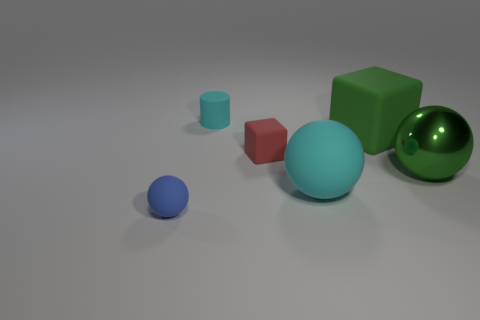Add 3 small red shiny cubes. How many objects exist? 9 Subtract all cylinders. How many objects are left? 5 Subtract all red cubes. Subtract all large green matte cubes. How many objects are left? 4 Add 1 big spheres. How many big spheres are left? 3 Add 4 yellow rubber balls. How many yellow rubber balls exist? 4 Subtract 0 gray balls. How many objects are left? 6 